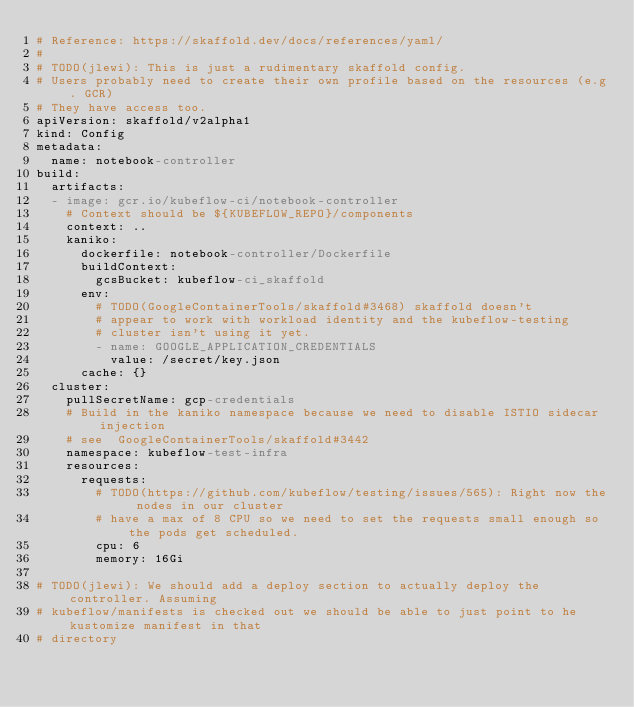<code> <loc_0><loc_0><loc_500><loc_500><_YAML_># Reference: https://skaffold.dev/docs/references/yaml/
#
# TODO(jlewi): This is just a rudimentary skaffold config.
# Users probably need to create their own profile based on the resources (e.g. GCR)
# They have access too.
apiVersion: skaffold/v2alpha1
kind: Config
metadata:
  name: notebook-controller
build:
  artifacts:
  - image: gcr.io/kubeflow-ci/notebook-controller
    # Context should be ${KUBEFLOW_REPO}/components
    context: ..
    kaniko:
      dockerfile: notebook-controller/Dockerfile
      buildContext:
        gcsBucket: kubeflow-ci_skaffold
      env: 
        # TODO(GoogleContainerTools/skaffold#3468) skaffold doesn't
        # appear to work with workload identity and the kubeflow-testing
        # cluster isn't using it yet.
        - name: GOOGLE_APPLICATION_CREDENTIALS
          value: /secret/key.json
      cache: {}
  cluster:
    pullSecretName: gcp-credentials
    # Build in the kaniko namespace because we need to disable ISTIO sidecar injection
    # see  GoogleContainerTools/skaffold#3442
    namespace: kubeflow-test-infra
    resources:
      requests:
        # TODO(https://github.com/kubeflow/testing/issues/565): Right now the nodes in our cluster
        # have a max of 8 CPU so we need to set the requests small enough so the pods get scheduled.
        cpu: 6
        memory: 16Gi

# TODO(jlewi): We should add a deploy section to actually deploy the controller. Assuming
# kubeflow/manifests is checked out we should be able to just point to he kustomize manifest in that
# directory</code> 